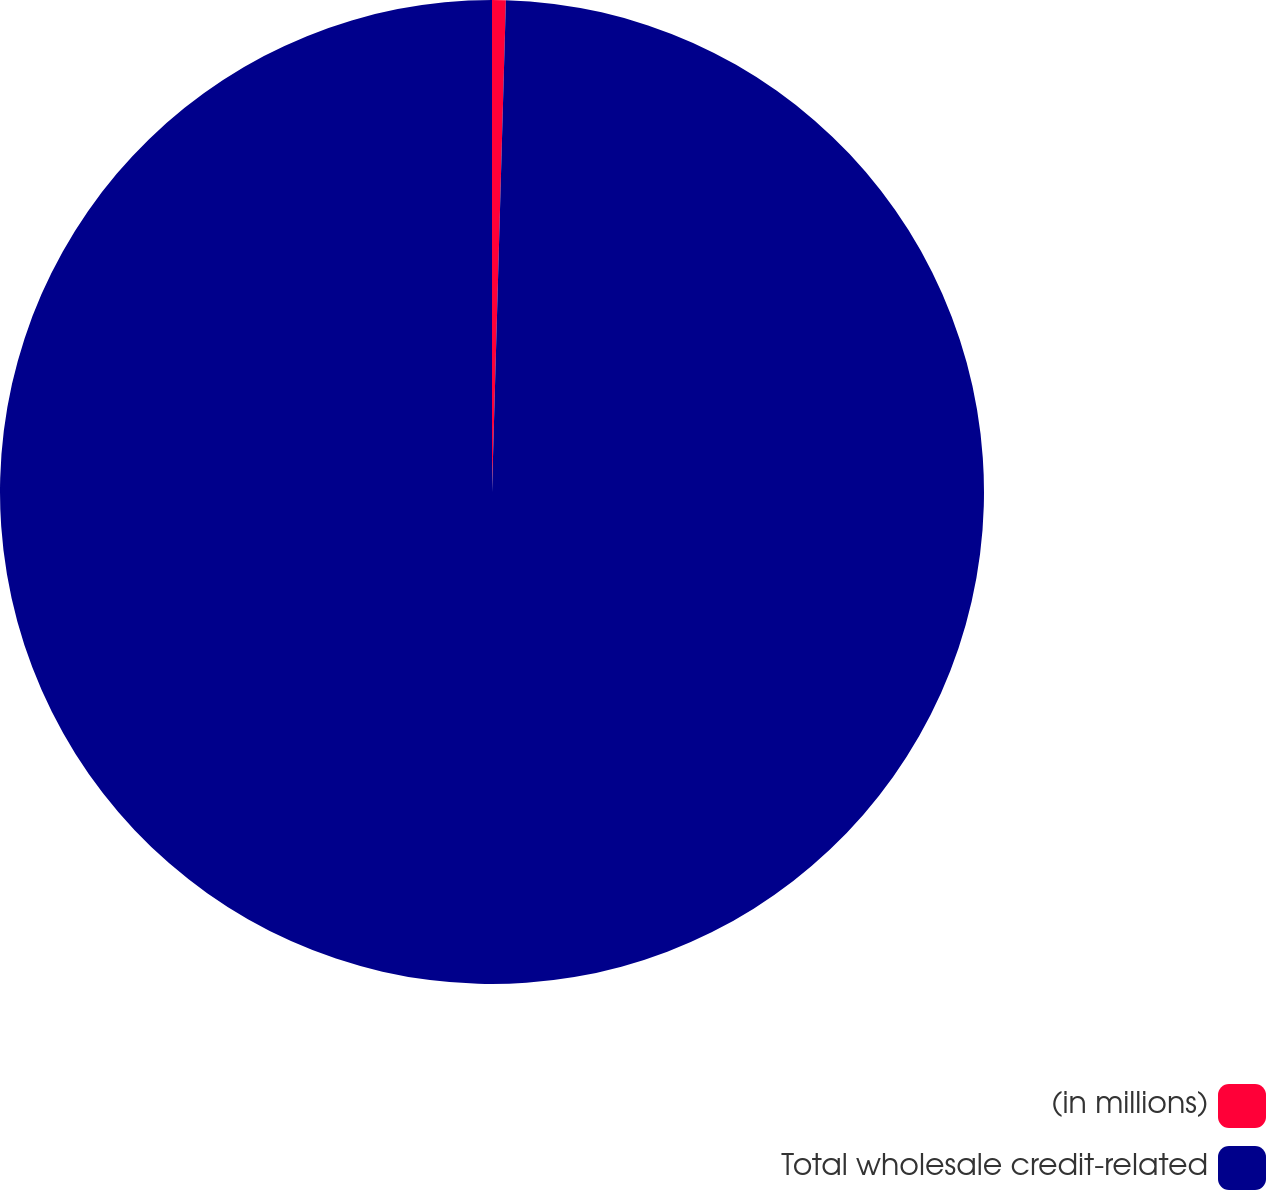Convert chart to OTSL. <chart><loc_0><loc_0><loc_500><loc_500><pie_chart><fcel>(in millions)<fcel>Total wholesale credit-related<nl><fcel>0.45%<fcel>99.55%<nl></chart> 